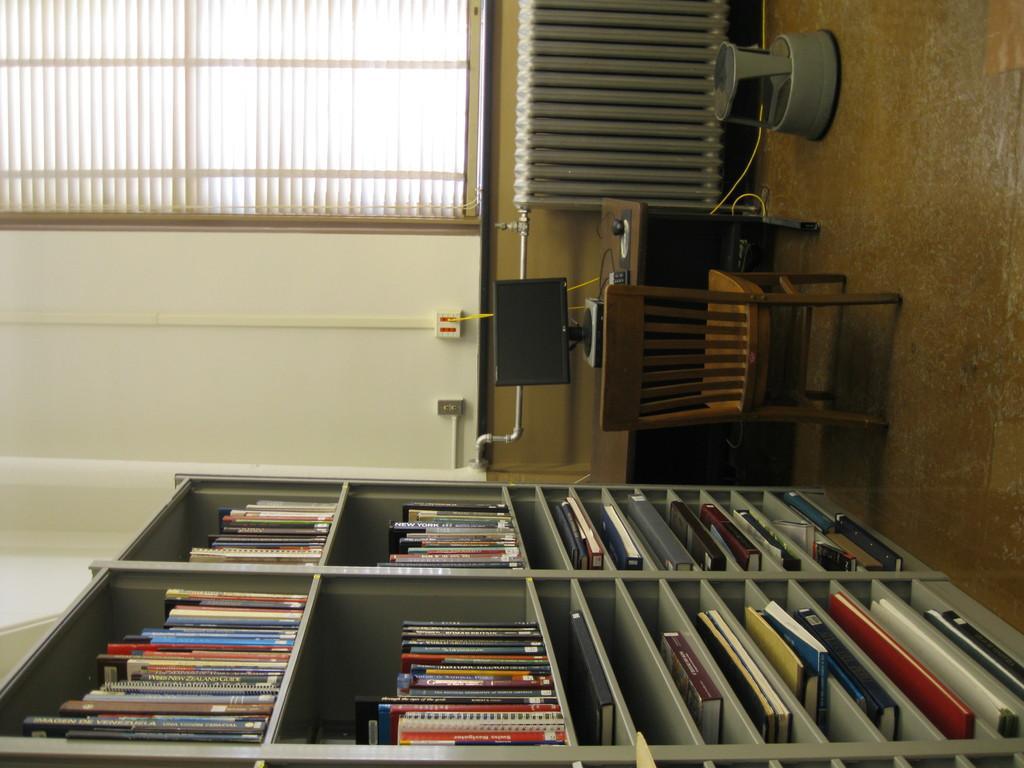Could you give a brief overview of what you see in this image? In the image we can see chair, table and on the table there is a system. Here we can see shelves and books on the shelves. Here we can see the floor, window and window blinds. 